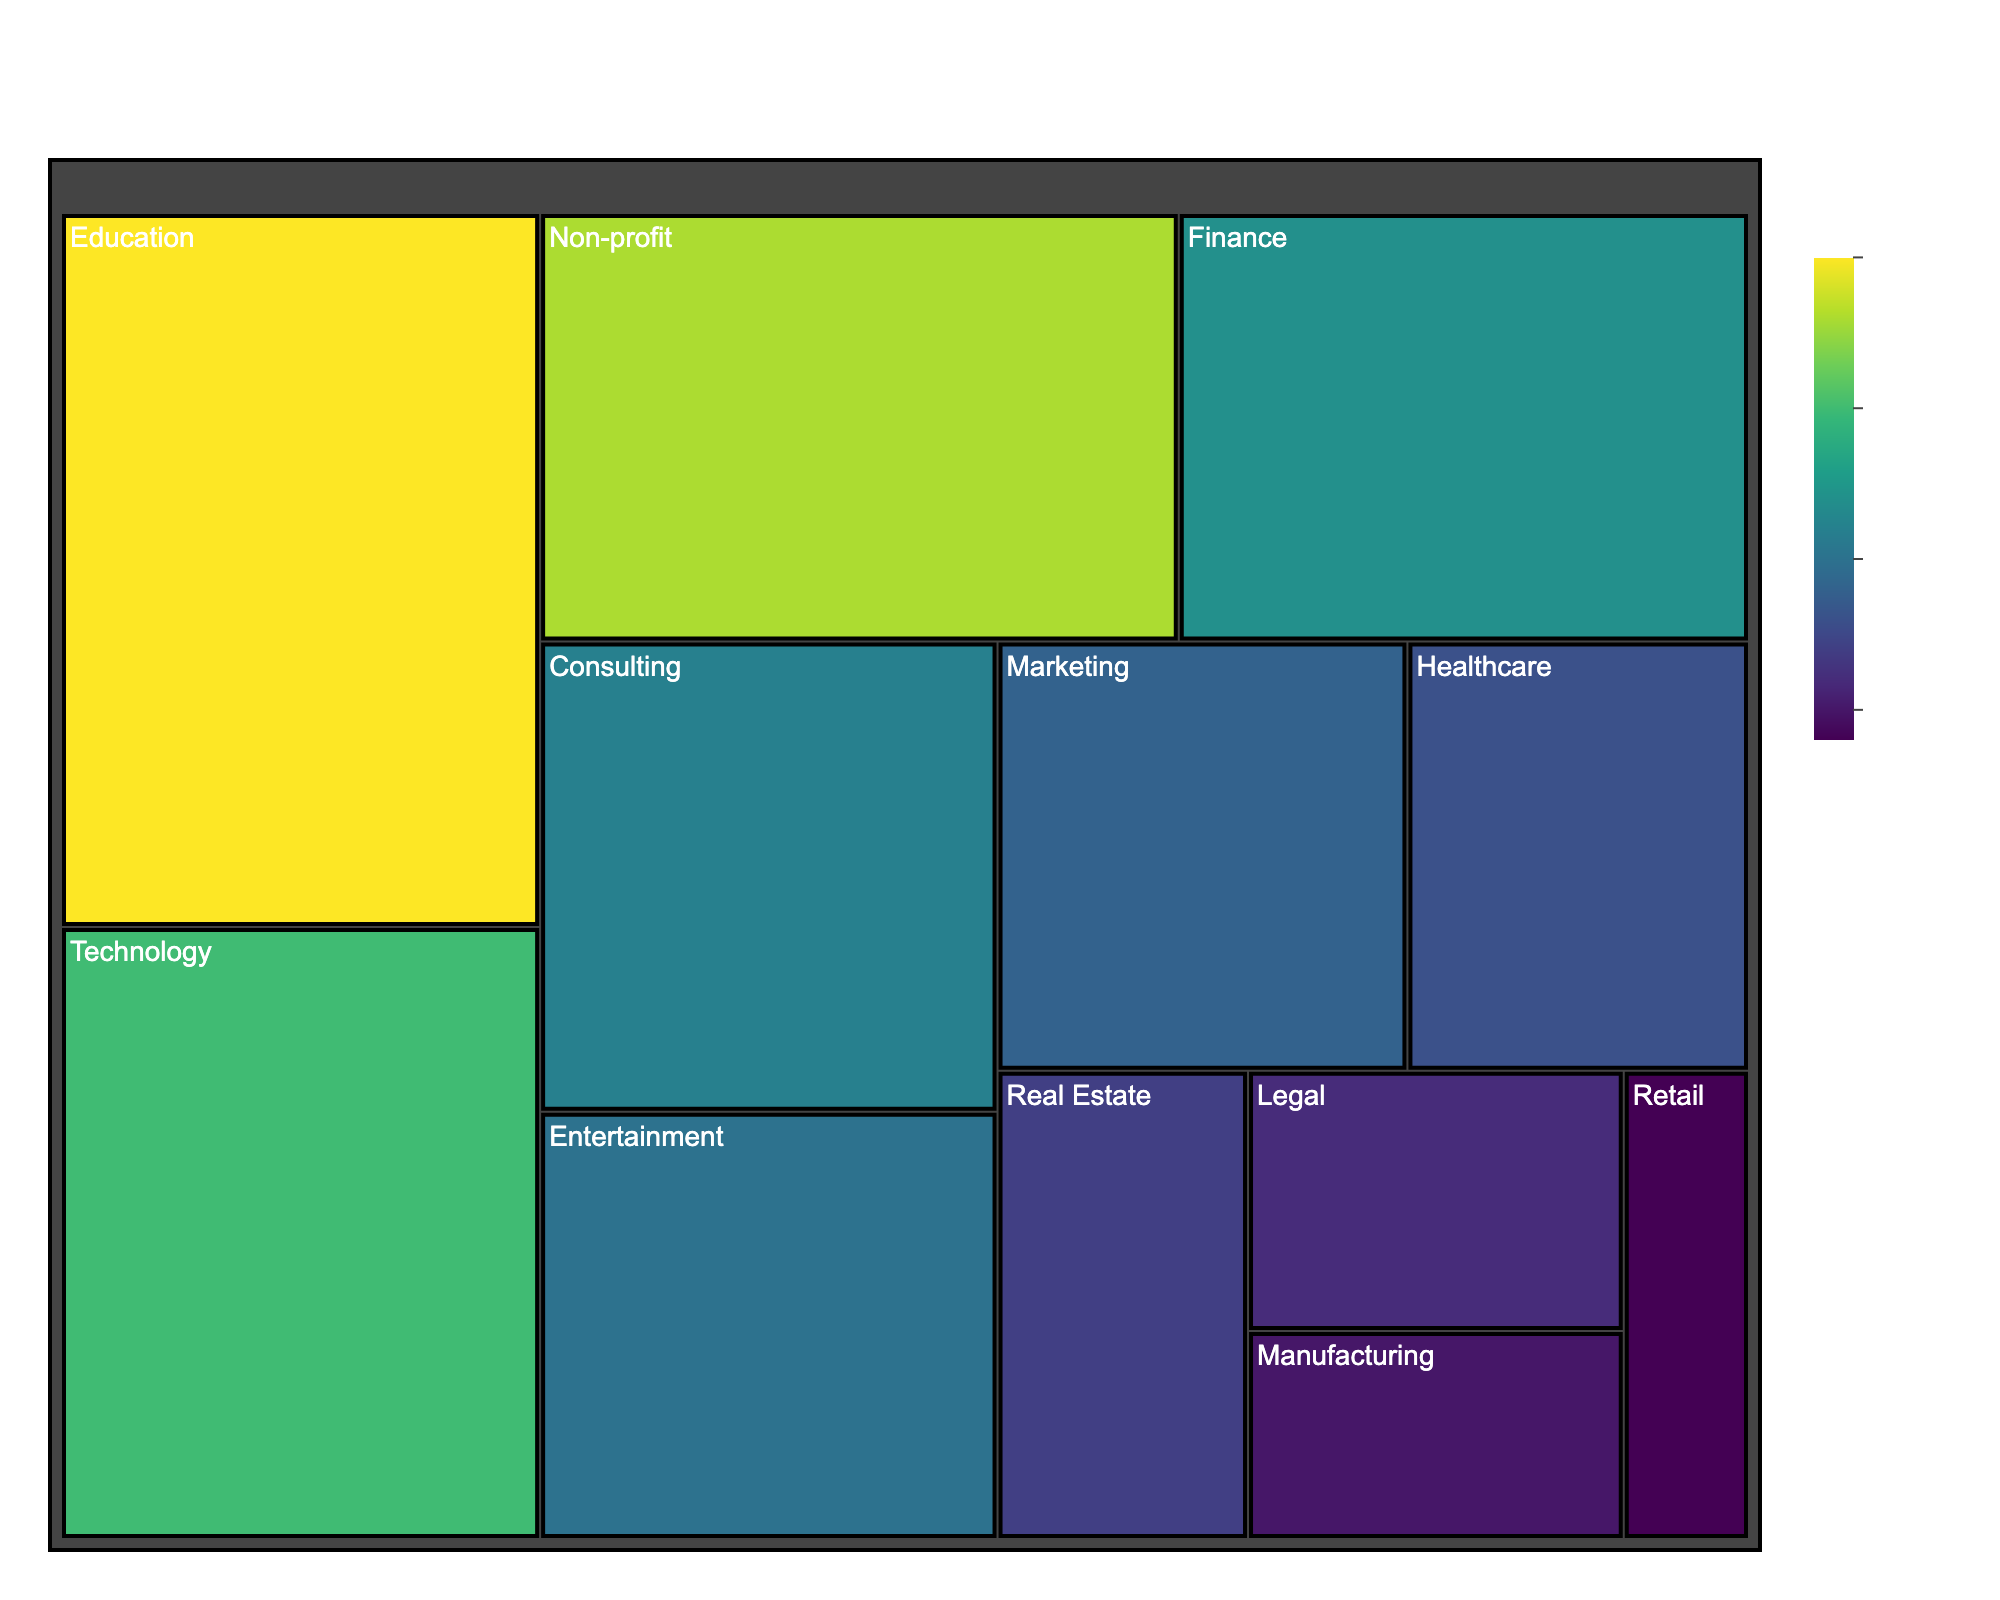What is the title of the treemap? The title is positioned at the top center of the figure and reads "Theodore Dan's Professional Network"
Answer: Theodore Dan's Professional Network Which industry has the highest "Years of Connection"? The color bar indicates "Years of Connection", with darker colors corresponding to higher values. The darkest color is in the "Education" sector.
Answer: Education What is the size of the "Healthcare" sector in Theodore's professional network? The size of each sector is indicated numerically within the treemap squares. For "Healthcare", the size is 15.
Answer: 15 What is the average number of years of connection across all the industry sectors? Add up all the "Years of Connection" values (15 + 12 + 20 + 8 + 10 + 18 + 6 + 9 + 7 + 11 + 5 + 4) = 125. There are 12 sectors, so divide the total by 12: 125/12 ≈ 10.42.
Answer: 10.42 Which two sectors have nearly equal sizes and what are their sizes? The "Marketing" and "Entertainment" sectors have sizes 18 and 20 respectively. They are the closest in size.
Answer: Marketing (18) and Entertainment (20) What is the combined size of the "Non-profit" and "Consulting" sectors in Theodore's network? Sum the sizes of "Non-profit" (28) and "Consulting" (22): 28 + 22 = 50.
Answer: 50 How many sectors have a "Years of Connection" value greater than or equal to 10? The sectors that meet this criterion are "Technology" (15), "Finance" (12), "Education" (20), "Entertainment" (10), "Non-profit" (18), and "Consulting" (11). There are 6 sectors in total.
Answer: 6 Which sector has both the smallest size and the fewest years of connection? The sector with the smallest size is "Retail" (size 6), which also has the fewest years of connection (4 years).
Answer: Retail (size 6, years 4) What is the difference in size between the "Technology" and "Legal" sectors? Subtract the size of "Legal" (10) from the size of "Technology" (30): 30 - 10 = 20.
Answer: 20 What is the average size of the sectors with more than 10 years of connection? The sectors with more than 10 years are "Technology" (30), "Finance" (25), "Education" (35), "Non-profit" (28), and "Consulting" (22). The total size is 30 + 25 + 35 + 28 + 22 = 140. There are 5 sectors, so the average size is 140/5 = 28.
Answer: 28 